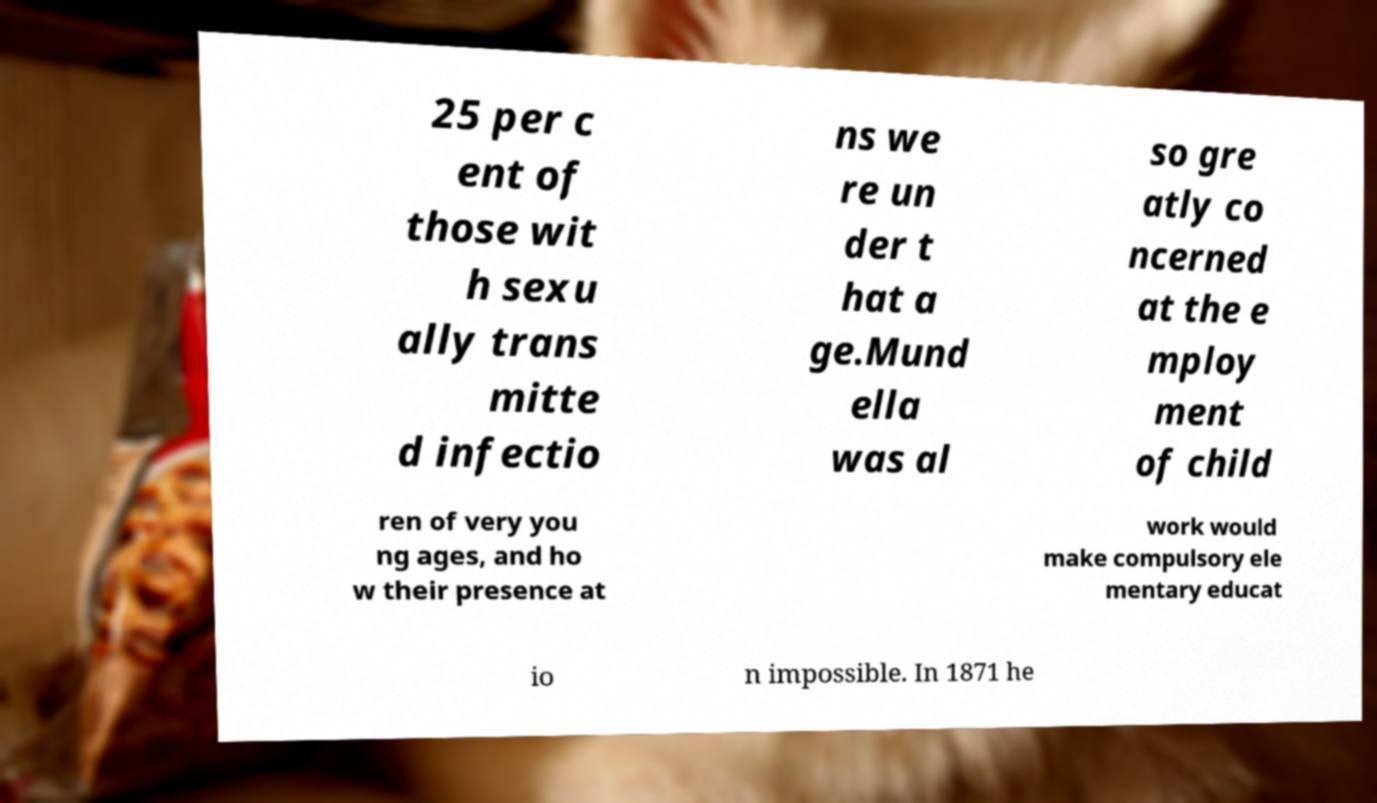Could you extract and type out the text from this image? 25 per c ent of those wit h sexu ally trans mitte d infectio ns we re un der t hat a ge.Mund ella was al so gre atly co ncerned at the e mploy ment of child ren of very you ng ages, and ho w their presence at work would make compulsory ele mentary educat io n impossible. In 1871 he 